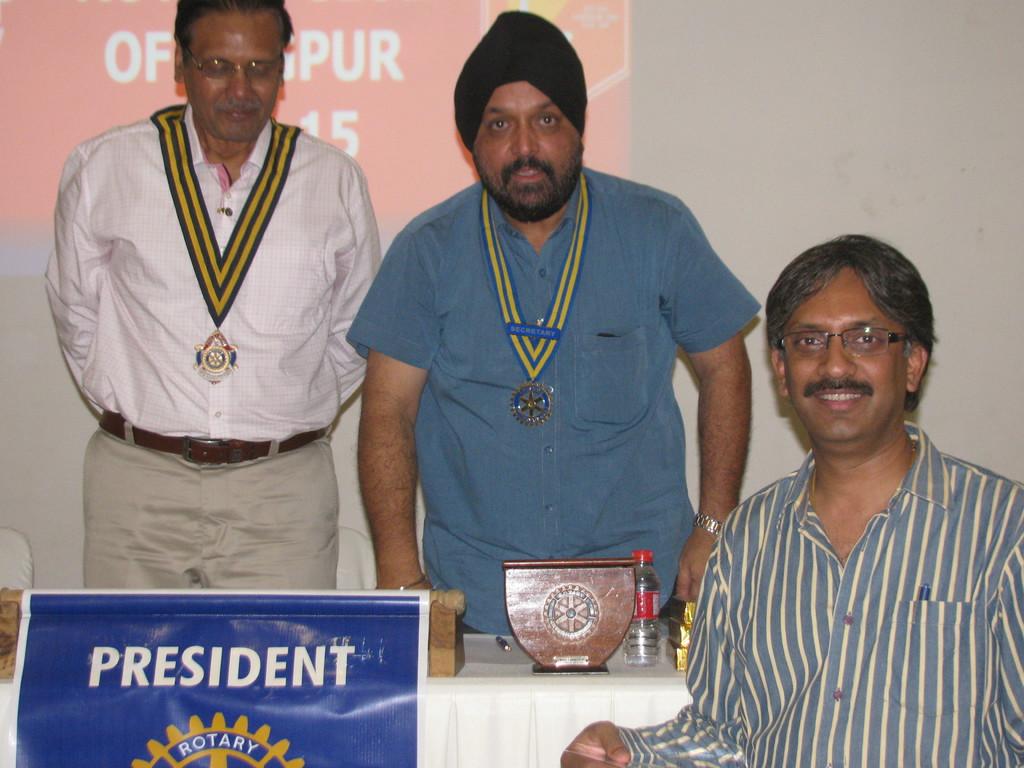What is the rotary title displayed?
Your answer should be very brief. President. 